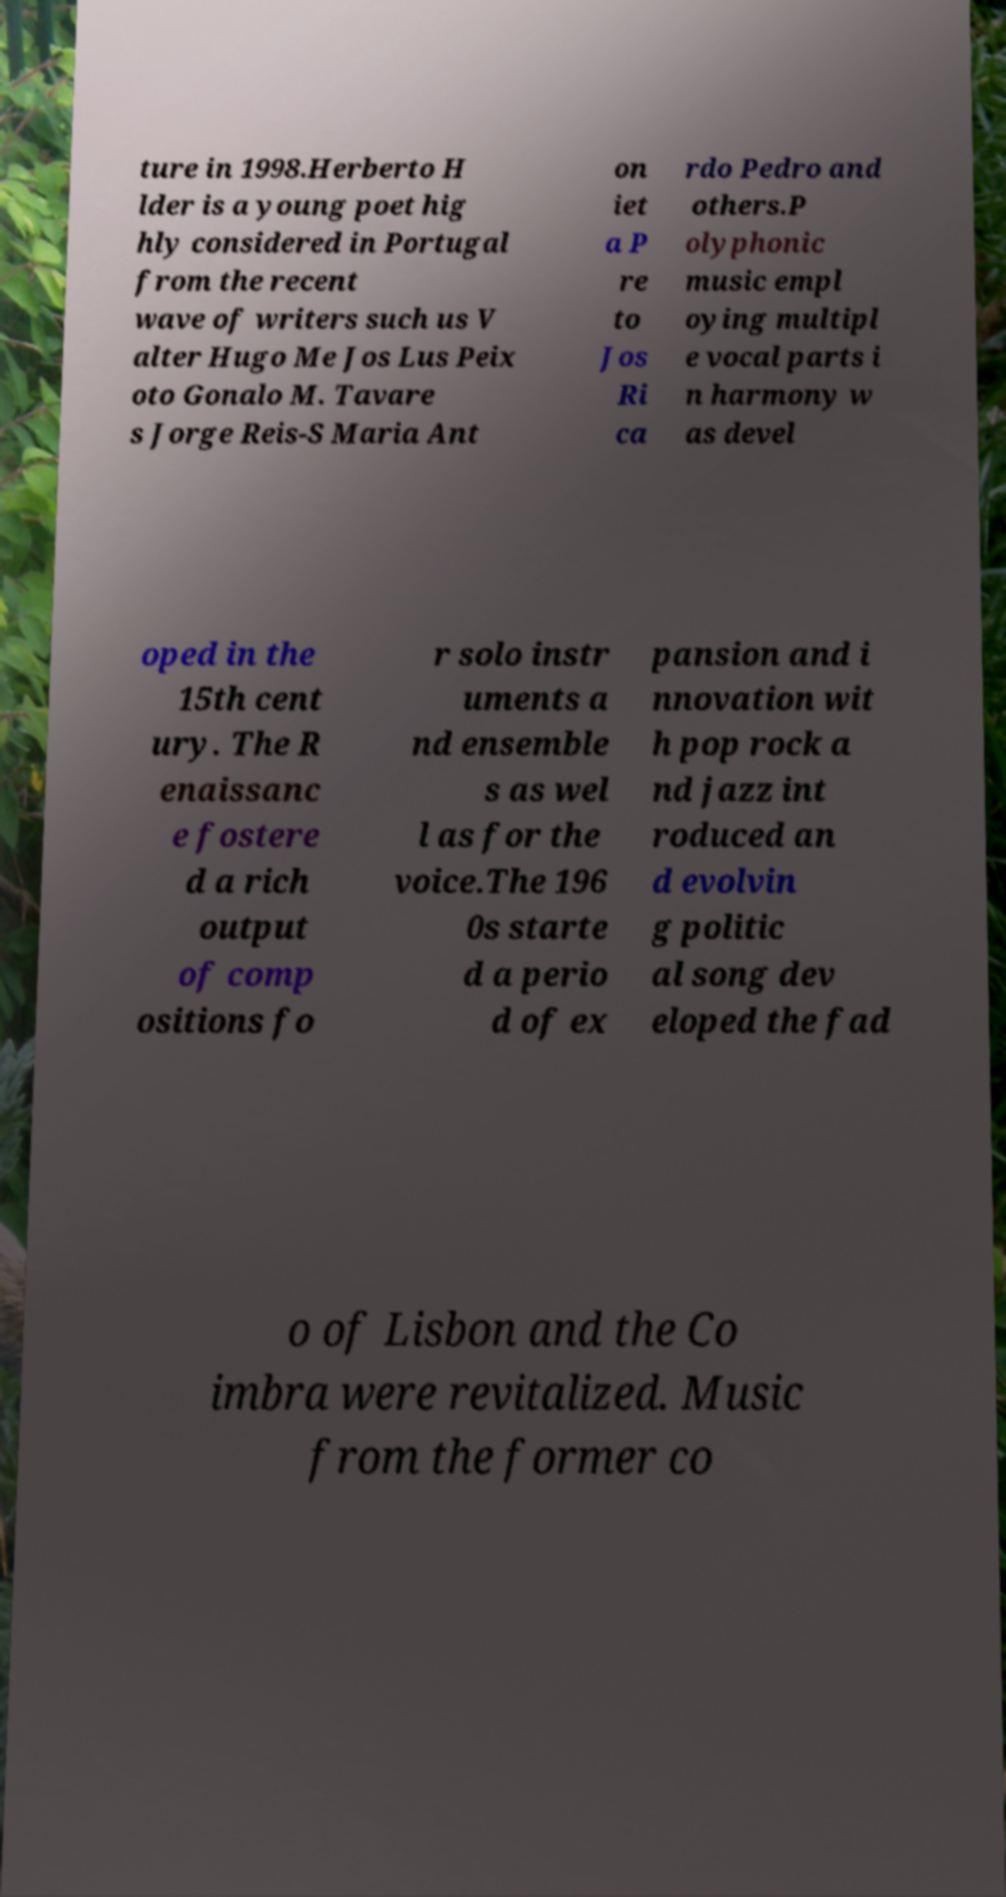Please read and relay the text visible in this image. What does it say? ture in 1998.Herberto H lder is a young poet hig hly considered in Portugal from the recent wave of writers such us V alter Hugo Me Jos Lus Peix oto Gonalo M. Tavare s Jorge Reis-S Maria Ant on iet a P re to Jos Ri ca rdo Pedro and others.P olyphonic music empl oying multipl e vocal parts i n harmony w as devel oped in the 15th cent ury. The R enaissanc e fostere d a rich output of comp ositions fo r solo instr uments a nd ensemble s as wel l as for the voice.The 196 0s starte d a perio d of ex pansion and i nnovation wit h pop rock a nd jazz int roduced an d evolvin g politic al song dev eloped the fad o of Lisbon and the Co imbra were revitalized. Music from the former co 